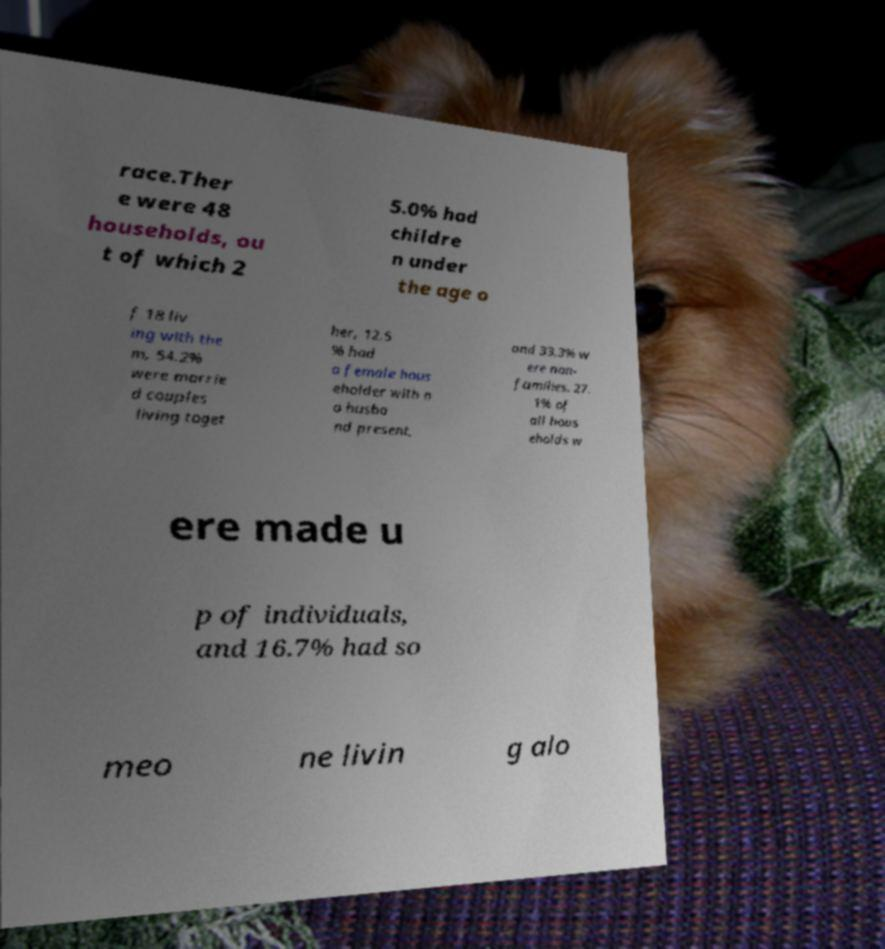Could you extract and type out the text from this image? race.Ther e were 48 households, ou t of which 2 5.0% had childre n under the age o f 18 liv ing with the m, 54.2% were marrie d couples living toget her, 12.5 % had a female hous eholder with n o husba nd present, and 33.3% w ere non- families. 27. 1% of all hous eholds w ere made u p of individuals, and 16.7% had so meo ne livin g alo 